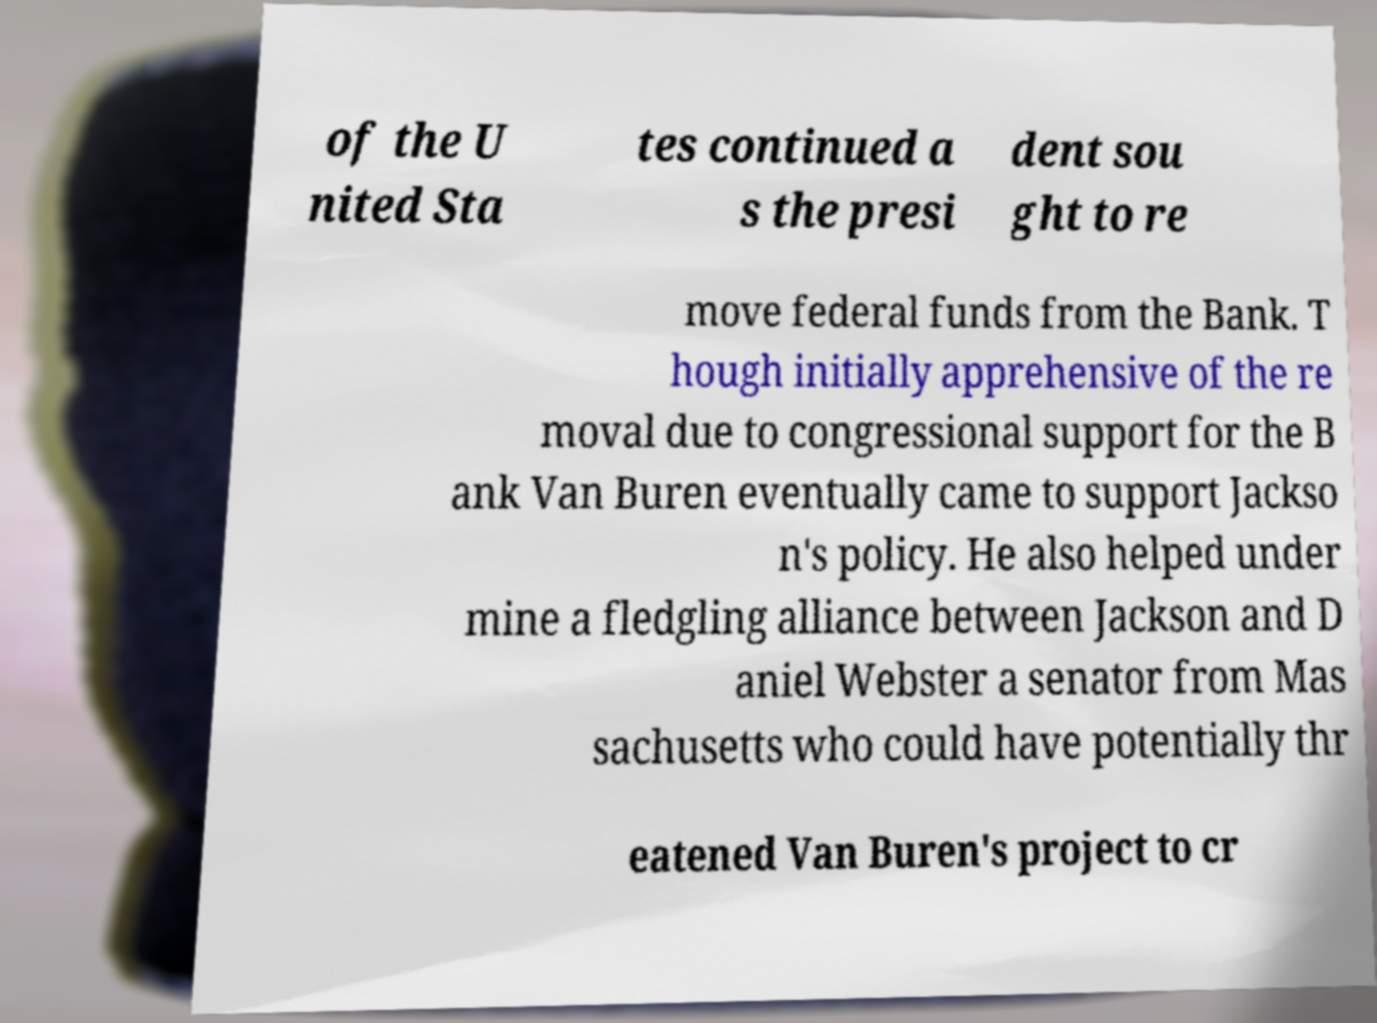Could you extract and type out the text from this image? of the U nited Sta tes continued a s the presi dent sou ght to re move federal funds from the Bank. T hough initially apprehensive of the re moval due to congressional support for the B ank Van Buren eventually came to support Jackso n's policy. He also helped under mine a fledgling alliance between Jackson and D aniel Webster a senator from Mas sachusetts who could have potentially thr eatened Van Buren's project to cr 